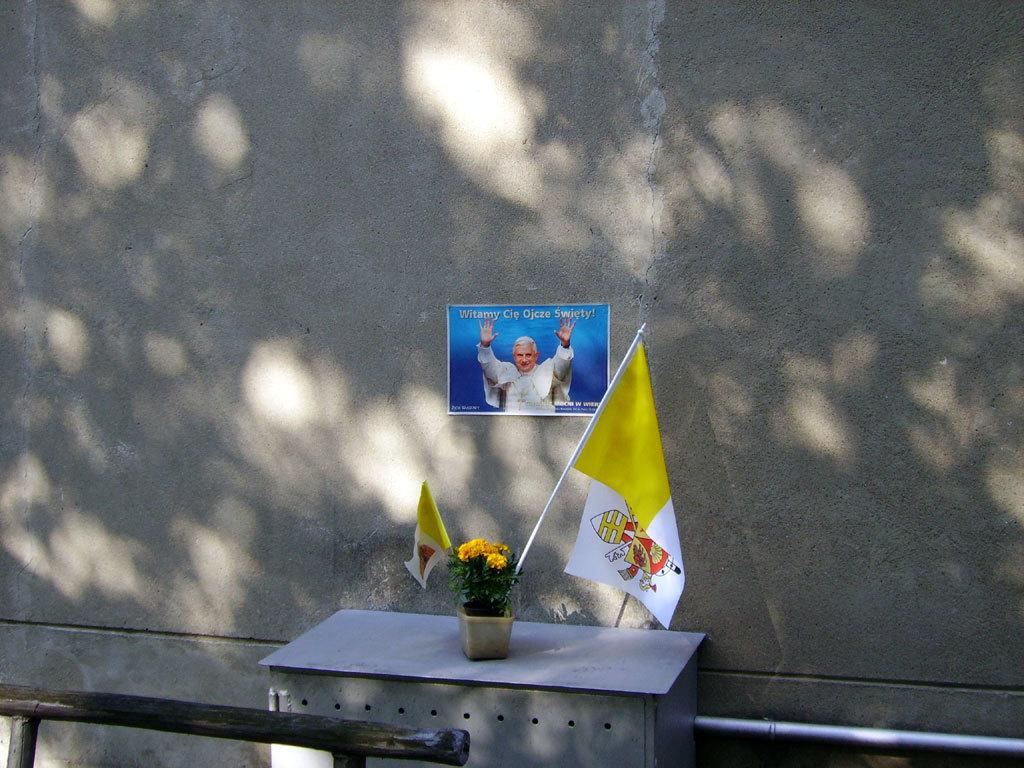Where was the image taken? The image was clicked outside. What is present on the table in the image? A: A plant is kept on the table in the image. How is the plant contained in the image? The plant is in a pot. What is unique about the plant's pot in the image? There is a yellow flag in the pot. What can be seen in the background of the image? There is a wall in the background of the image. What is hung on the wall in the image? A poster is kept on the wall. How many goldfish are swimming in the pot with the plant? There are no goldfish present in the image; it features a plant in a pot with a yellow flag. What type of powder is sprinkled on the poster in the image? There is no powder present on the poster or anywhere else in the image. 